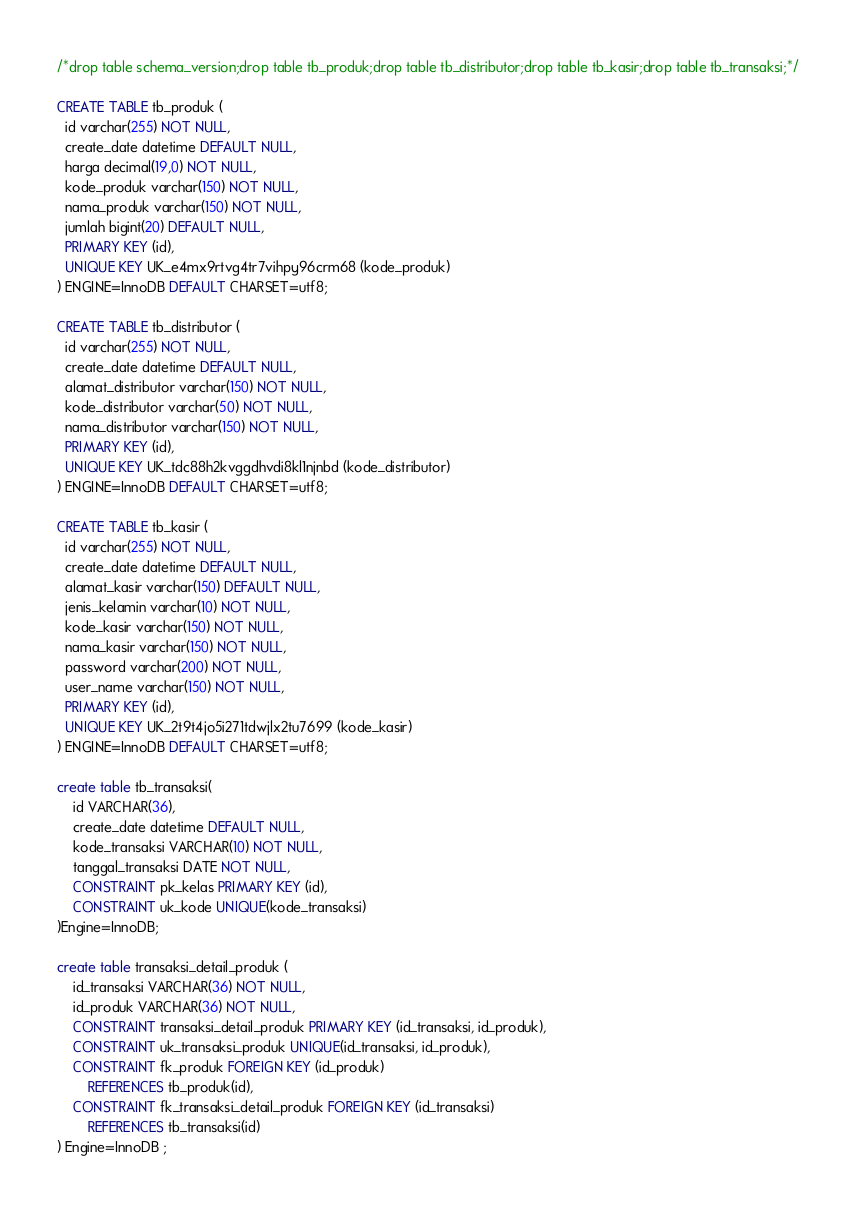Convert code to text. <code><loc_0><loc_0><loc_500><loc_500><_SQL_>/*drop table schema_version;drop table tb_produk;drop table tb_distributor;drop table tb_kasir;drop table tb_transaksi;*/

CREATE TABLE tb_produk (
  id varchar(255) NOT NULL,
  create_date datetime DEFAULT NULL,
  harga decimal(19,0) NOT NULL,
  kode_produk varchar(150) NOT NULL,
  nama_produk varchar(150) NOT NULL,
  jumlah bigint(20) DEFAULT NULL,
  PRIMARY KEY (id),
  UNIQUE KEY UK_e4mx9rtvg4tr7vihpy96crm68 (kode_produk)
) ENGINE=InnoDB DEFAULT CHARSET=utf8;

CREATE TABLE tb_distributor (
  id varchar(255) NOT NULL,
  create_date datetime DEFAULT NULL,
  alamat_distributor varchar(150) NOT NULL,
  kode_distributor varchar(50) NOT NULL,
  nama_distributor varchar(150) NOT NULL,
  PRIMARY KEY (id),
  UNIQUE KEY UK_tdc88h2kvggdhvdi8kl1njnbd (kode_distributor)
) ENGINE=InnoDB DEFAULT CHARSET=utf8;

CREATE TABLE tb_kasir (
  id varchar(255) NOT NULL,
  create_date datetime DEFAULT NULL,
  alamat_kasir varchar(150) DEFAULT NULL,
  jenis_kelamin varchar(10) NOT NULL,
  kode_kasir varchar(150) NOT NULL,
  nama_kasir varchar(150) NOT NULL,
  password varchar(200) NOT NULL,
  user_name varchar(150) NOT NULL,
  PRIMARY KEY (id),
  UNIQUE KEY UK_2t9t4jo5i271tdwjlx2tu7699 (kode_kasir)
) ENGINE=InnoDB DEFAULT CHARSET=utf8;

create table tb_transaksi(
    id VARCHAR(36),
    create_date datetime DEFAULT NULL,
    kode_transaksi VARCHAR(10) NOT NULL,
    tanggal_transaksi DATE NOT NULL,
    CONSTRAINT pk_kelas PRIMARY KEY (id),
    CONSTRAINT uk_kode UNIQUE(kode_transaksi)
)Engine=InnoDB;

create table transaksi_detail_produk (
    id_transaksi VARCHAR(36) NOT NULL,
    id_produk VARCHAR(36) NOT NULL,
    CONSTRAINT transaksi_detail_produk PRIMARY KEY (id_transaksi, id_produk),
    CONSTRAINT uk_transaksi_produk UNIQUE(id_transaksi, id_produk),
    CONSTRAINT fk_produk FOREIGN KEY (id_produk) 
        REFERENCES tb_produk(id),
    CONSTRAINT fk_transaksi_detail_produk FOREIGN KEY (id_transaksi) 
        REFERENCES tb_transaksi(id)
) Engine=InnoDB ;

</code> 